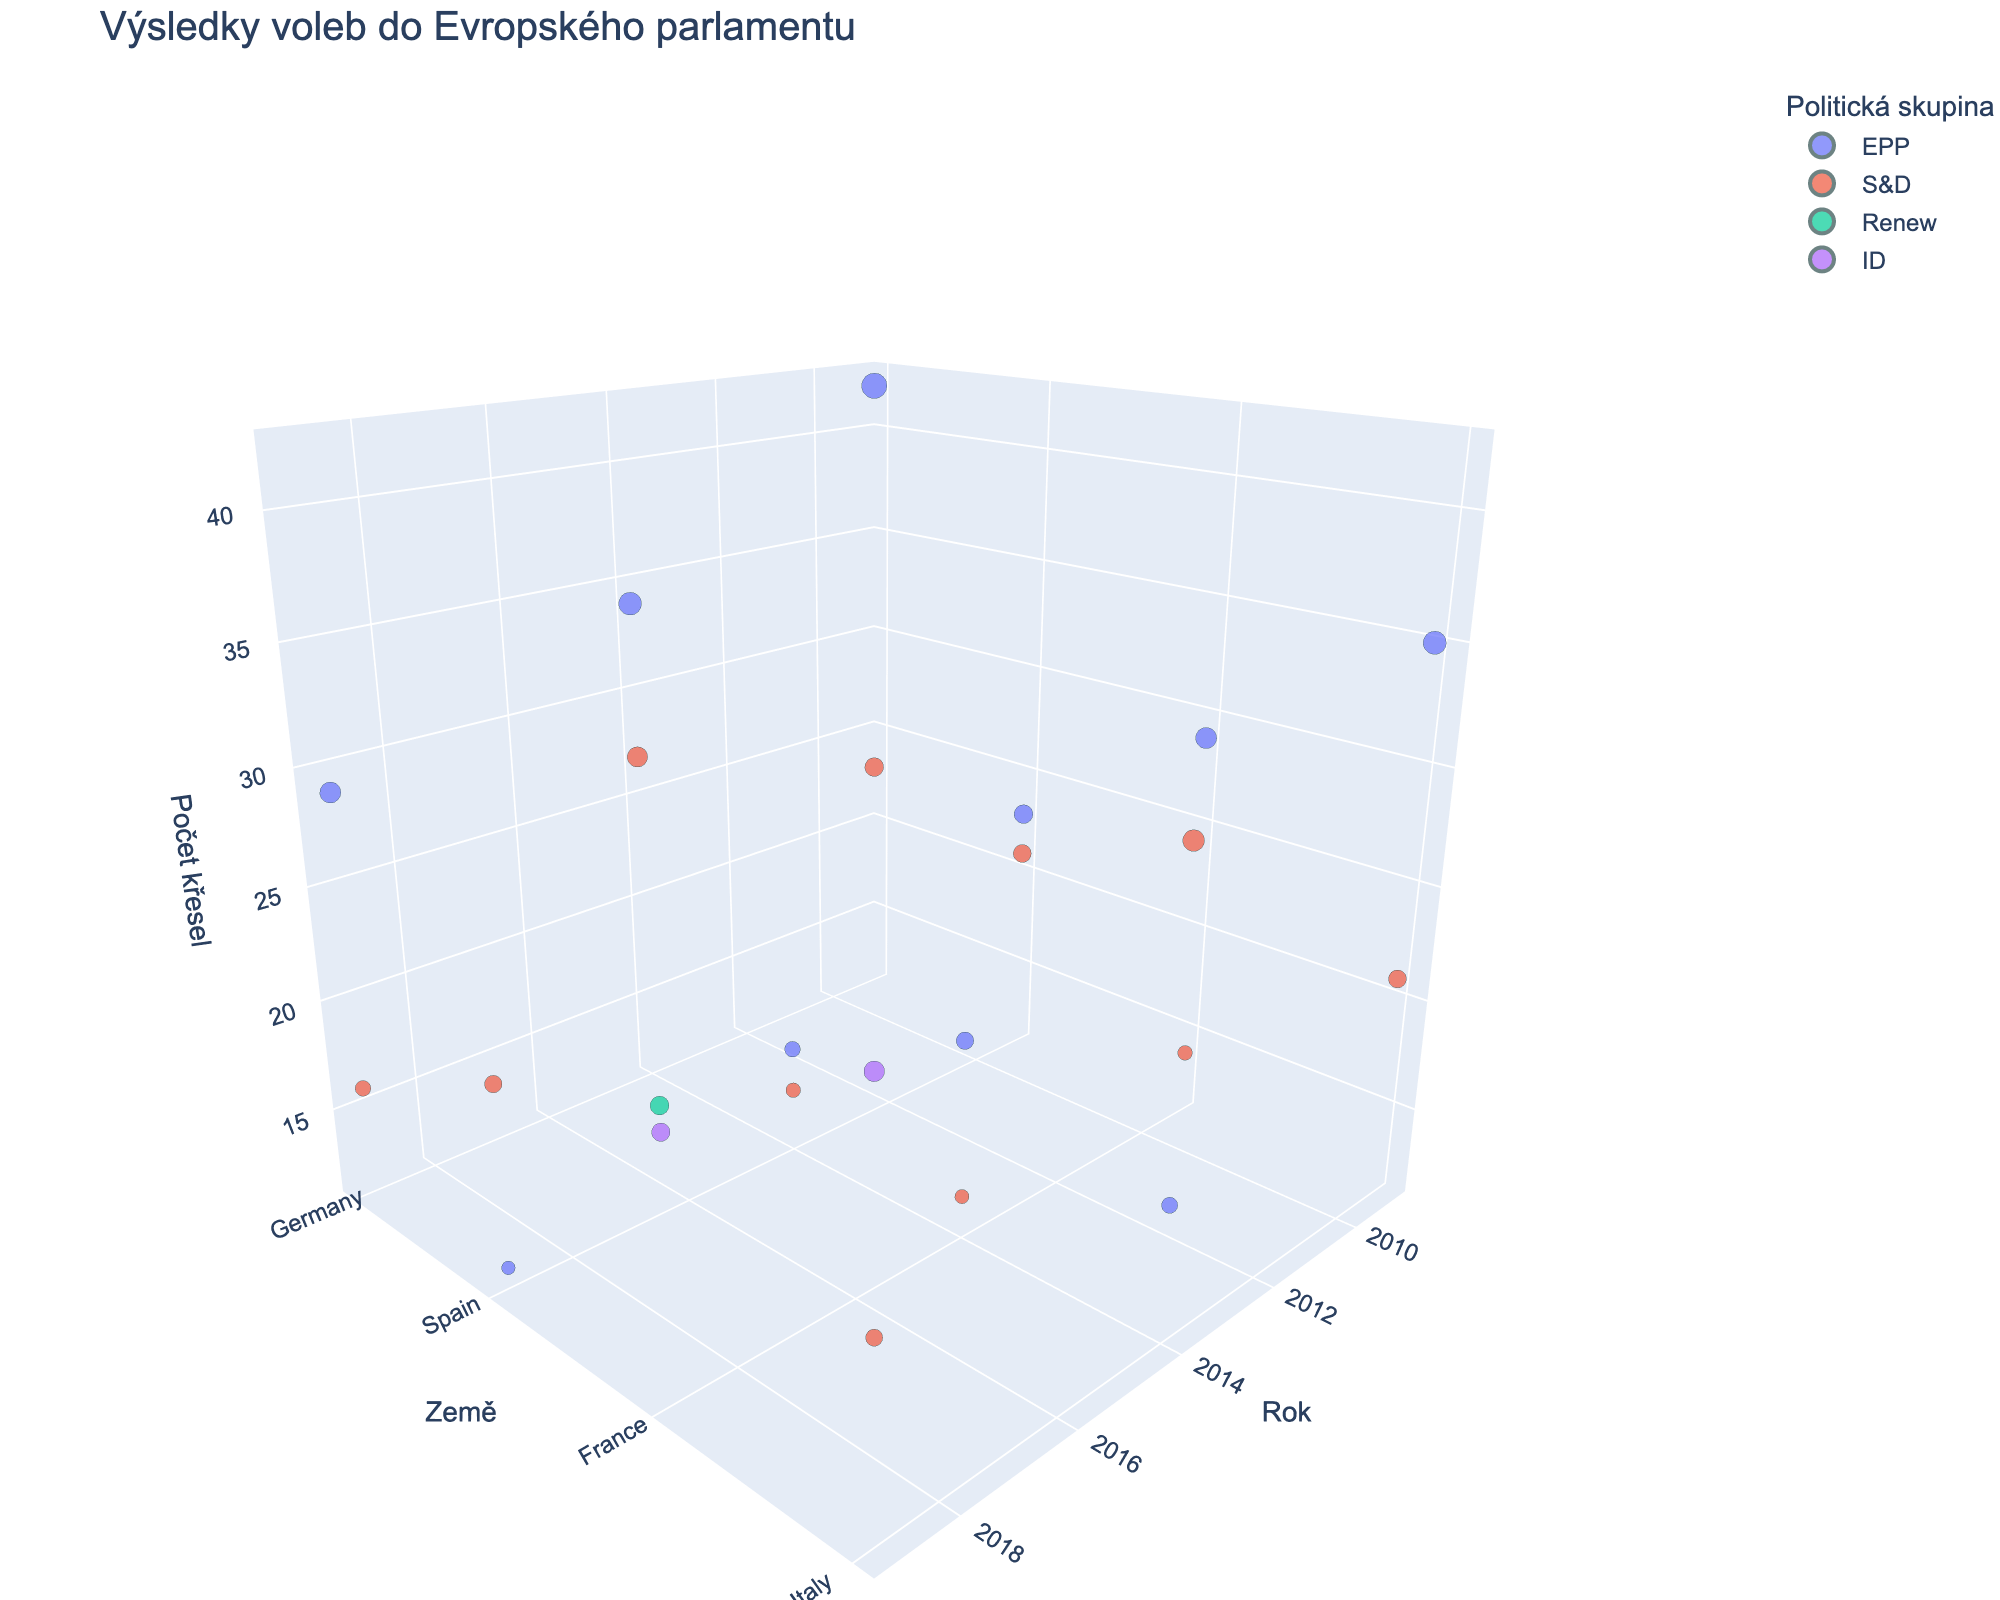What is the title of the figure? The title of the figure is displayed at the top and provides a brief description of the visualization.
Answer: Výsledky voleb do Evropského parlamentu Which country and political group combination had the most seats in 2009? To determine this, look at the z-axis for 2009 and find the highest data point.
Answer: Germany, EPP Compare the number of seats for the S&D group in Spain between 2009 and 2019. Identify the data points for Spain in 2009 and 2019 for the S&D group and compare their z-axis values.
Answer: 2009: 21, 2019: 20 What is the overall trend for the EPP group in Germany from 2009 to 2019? Observe the data points for the EPP group in Germany across the years 2009, 2014, and 2019 by following the x-axis and noting the z-axis values.
Answer: Decreasing Which political group has the largest representation in Italy in 2019? Look at the data points for Italy in 2019 and identify the political group with the highest z-axis value.
Answer: ID Compare the total number of seats for EPP and S&D groups in France across all years. Sum the z-axis values for EPP and S&D groups in France for the years 2009, 2014, and 2019, then compare the totals.
Answer: EPP: 49, S&D: 27 Among the listed countries, which has the most diverse political representation in 2019? Identify which country has the most varied political groups (different colors) in 2019.
Answer: France What is the combined seat count for the Renew group in 2019 for all countries? Sum the z-axis values for the Renew group across all countries for the year 2019.
Answer: 23 Which country showed the most significant drop in EPP seats from 2009 to 2019? Calculate the difference in EPP seats for each country between 2009 and 2019 and find the largest decrease.
Answer: Germany (42 to 29, a drop of 13) How many political groups are represented in the 3D plot? Look at the different colors used in the legend to find the total number of unique political groups.
Answer: 4 